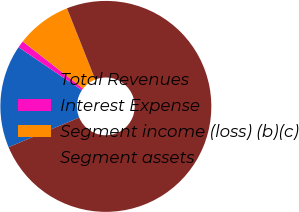Convert chart to OTSL. <chart><loc_0><loc_0><loc_500><loc_500><pie_chart><fcel>Total Revenues<fcel>Interest Expense<fcel>Segment income (loss) (b)(c)<fcel>Segment assets<nl><fcel>15.8%<fcel>1.08%<fcel>8.44%<fcel>74.68%<nl></chart> 